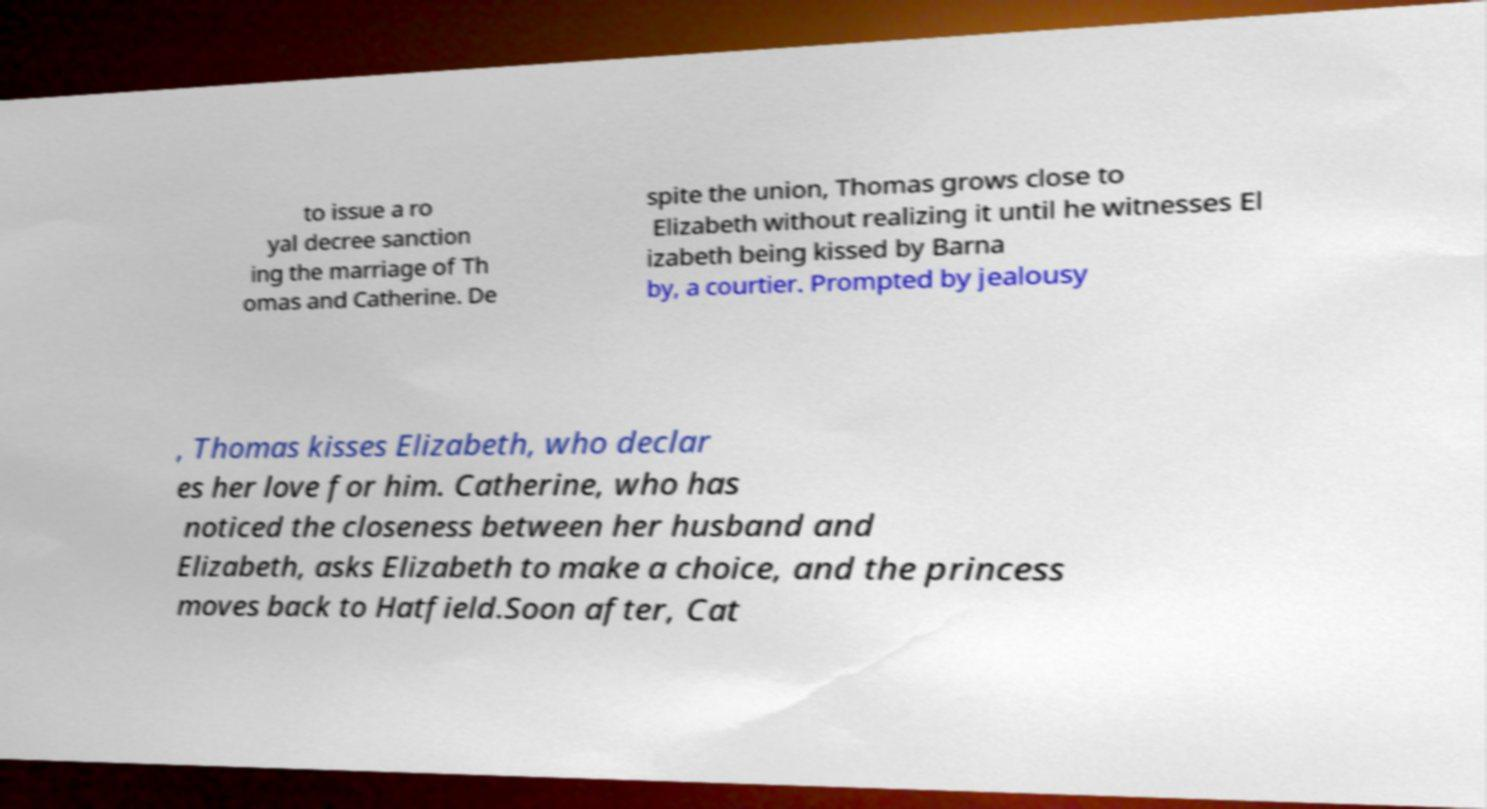Please identify and transcribe the text found in this image. to issue a ro yal decree sanction ing the marriage of Th omas and Catherine. De spite the union, Thomas grows close to Elizabeth without realizing it until he witnesses El izabeth being kissed by Barna by, a courtier. Prompted by jealousy , Thomas kisses Elizabeth, who declar es her love for him. Catherine, who has noticed the closeness between her husband and Elizabeth, asks Elizabeth to make a choice, and the princess moves back to Hatfield.Soon after, Cat 